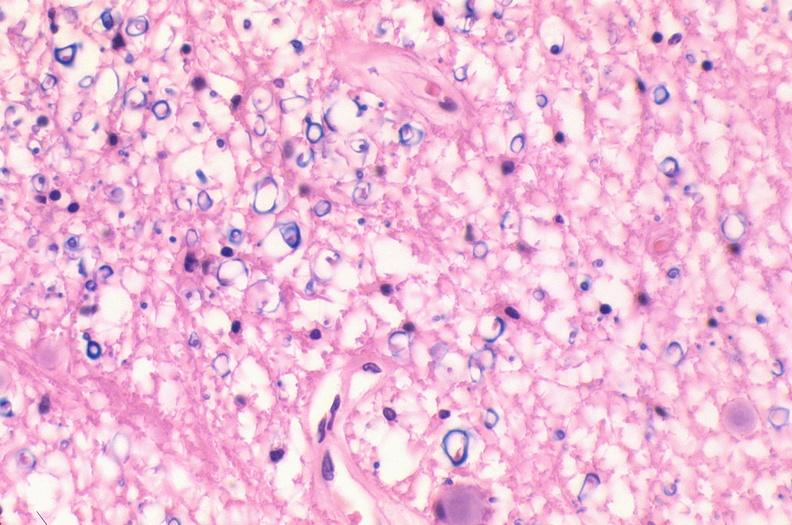does this image show spinal cord injury due to vertebral column trauma, demyelination?
Answer the question using a single word or phrase. Yes 